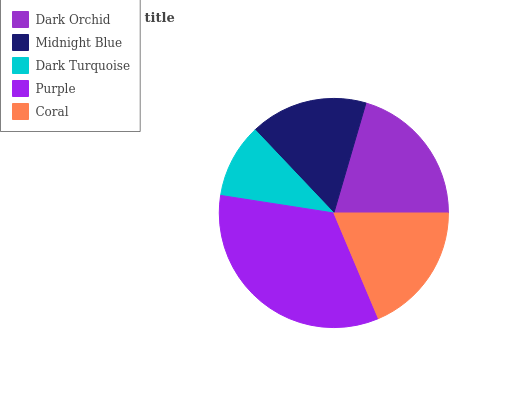Is Dark Turquoise the minimum?
Answer yes or no. Yes. Is Purple the maximum?
Answer yes or no. Yes. Is Midnight Blue the minimum?
Answer yes or no. No. Is Midnight Blue the maximum?
Answer yes or no. No. Is Dark Orchid greater than Midnight Blue?
Answer yes or no. Yes. Is Midnight Blue less than Dark Orchid?
Answer yes or no. Yes. Is Midnight Blue greater than Dark Orchid?
Answer yes or no. No. Is Dark Orchid less than Midnight Blue?
Answer yes or no. No. Is Coral the high median?
Answer yes or no. Yes. Is Coral the low median?
Answer yes or no. Yes. Is Midnight Blue the high median?
Answer yes or no. No. Is Purple the low median?
Answer yes or no. No. 